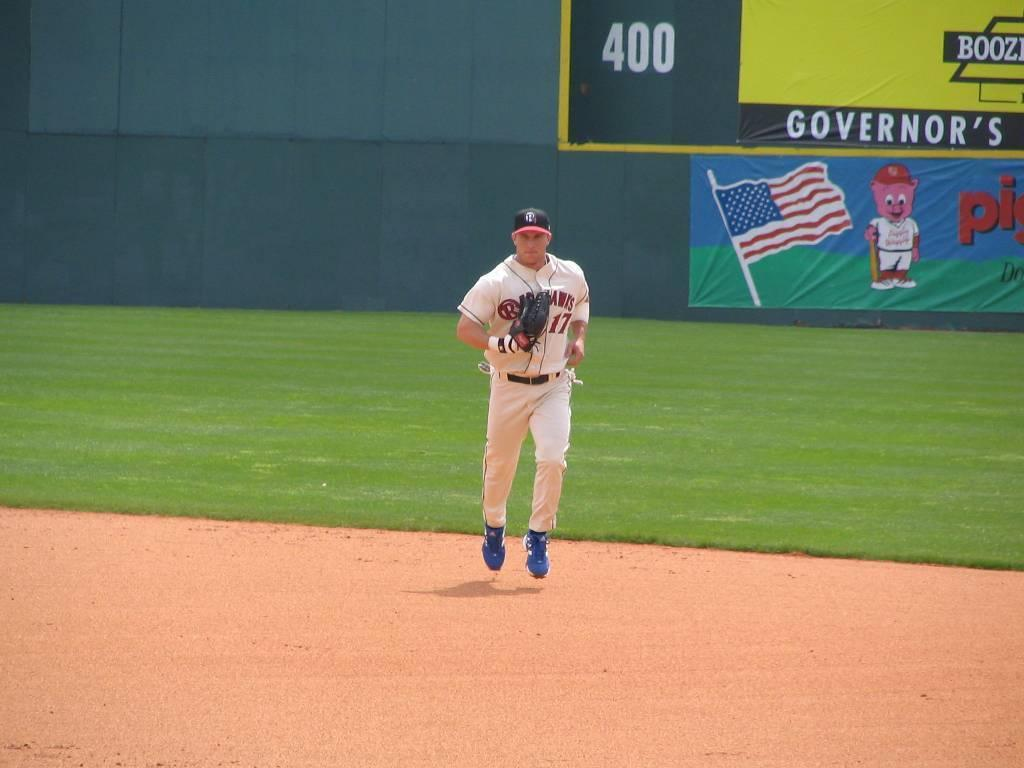<image>
Create a compact narrative representing the image presented. a sign in the outfield that says governor's on it 